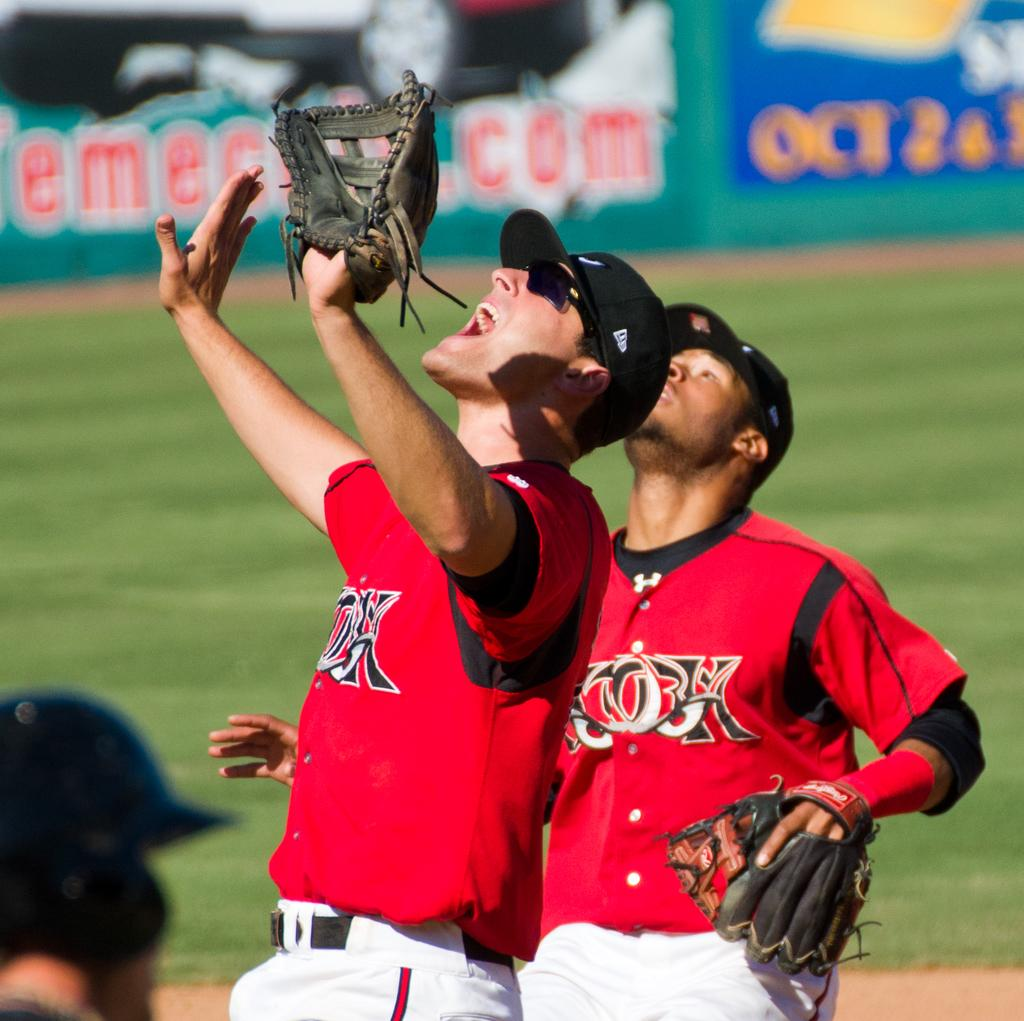<image>
Write a terse but informative summary of the picture. Two baseball players are wearing jerseys that say CO3H 